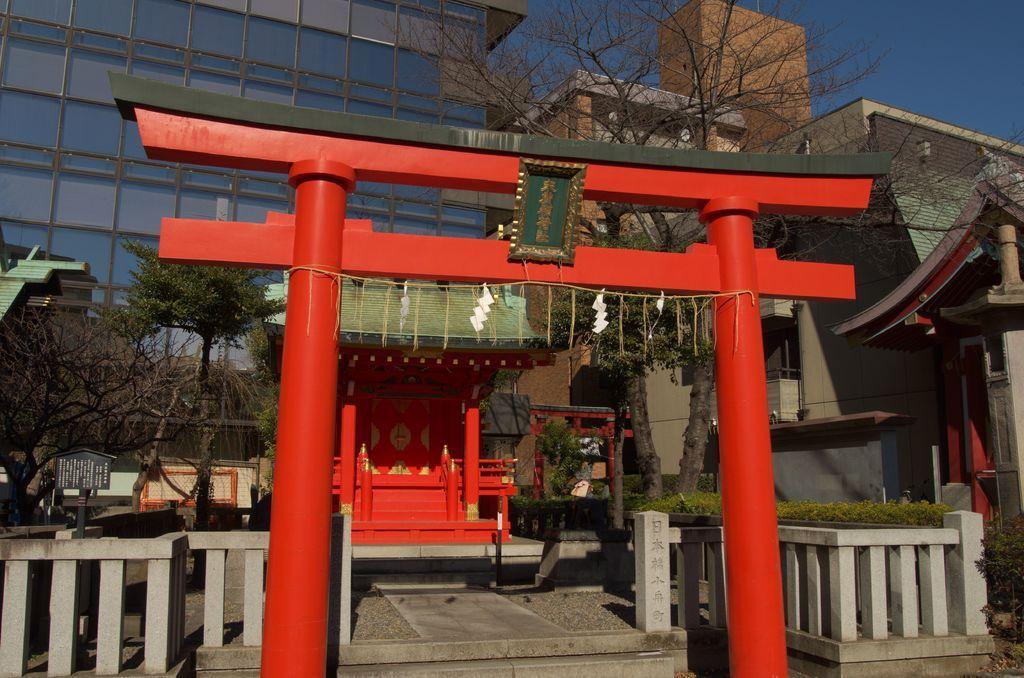Can you describe this image briefly? In this image, we can see an arch and decorative objects. At the bottom, we can see railings, stairs and walkway. Background there are few trees, buildings, walls, glass objects, railings, stairs, plants and a few things. On the right side background, we can see the sky. 